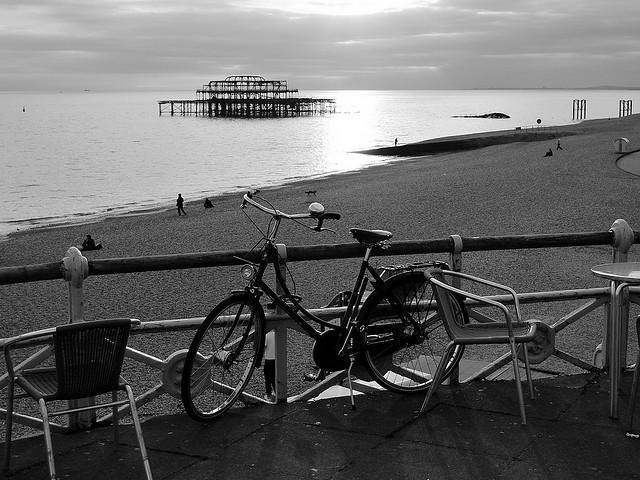How many chairs are on the deck?
Give a very brief answer. 2. How many dining tables are visible?
Give a very brief answer. 1. How many chairs are there?
Give a very brief answer. 2. How many black umbrellas are on the walkway?
Give a very brief answer. 0. 